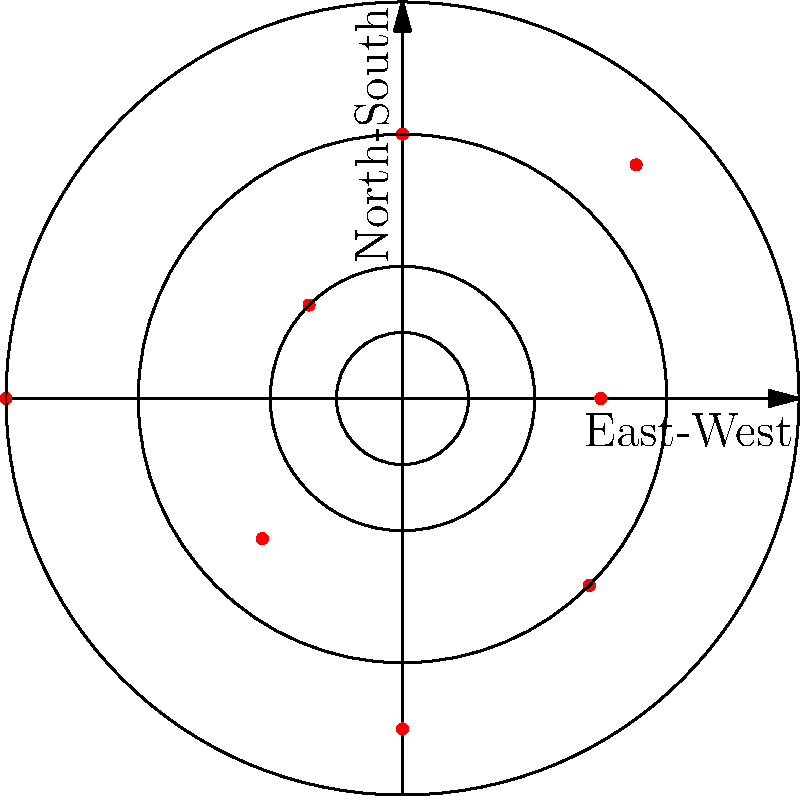During your time as an evacuee in the United States, you received news about the spread of rationing centers across London. The polar grid above represents the distribution of these centers, with each red dot indicating a center's location. The concentric circles represent distances of 2, 4, and 6 miles from the city center. In which quadrant of London were rationing centers most concentrated? To determine the quadrant with the highest concentration of rationing centers, we need to analyze the distribution of red dots in each quadrant:

1. Divide the polar grid into four quadrants:
   - Northeast (NE): Between 0° and 90°
   - Northwest (NW): Between 90° and 180°
   - Southwest (SW): Between 180° and 270°
   - Southeast (SE): Between 270° and 360°

2. Count the number of red dots in each quadrant:
   - NE: 2 dots
   - NW: 2 dots
   - SW: 2 dots
   - SE: 2 dots

3. Observe the distance of dots from the center in each quadrant:
   - NE: One dot at distance 5, one at distance 4
   - NW: One dot at distance 2, one at distance 6
   - SW: One dot at distance 3, one at distance 5
   - SE: One dot at distance 4, one at distance 3

4. Calculate the average distance for each quadrant:
   - NE: (5 + 4) / 2 = 4.5
   - NW: (2 + 6) / 2 = 4
   - SW: (3 + 5) / 2 = 4
   - SE: (4 + 3) / 2 = 3.5

5. Conclude that the Southeast (SE) quadrant has the lowest average distance, indicating the highest concentration of rationing centers.
Answer: Southeast (SE) quadrant 